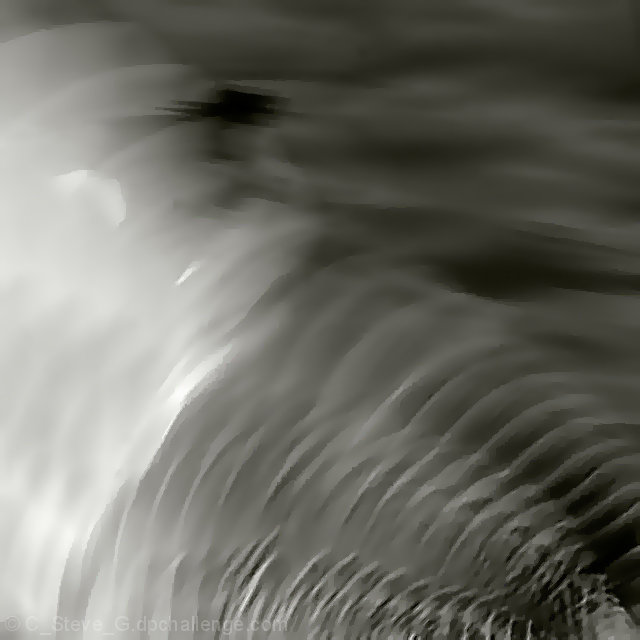What could this image possibly represent or symbolize? The abstract nature of this image allows for a multitude of interpretations. It may represent the fluidity of time or the malleable nature of reality. Alternatively, it could symbolize movement and change, as the patterns flow and shift, never remaining static. 